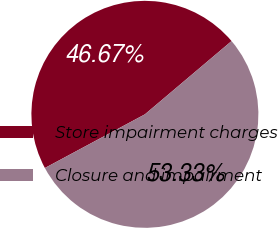Convert chart. <chart><loc_0><loc_0><loc_500><loc_500><pie_chart><fcel>Store impairment charges<fcel>Closure and impairment<nl><fcel>46.67%<fcel>53.33%<nl></chart> 